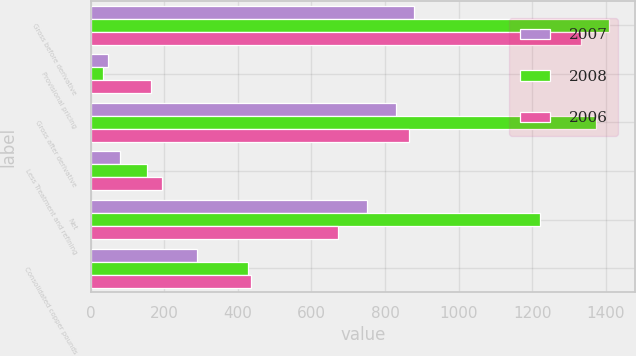Convert chart. <chart><loc_0><loc_0><loc_500><loc_500><stacked_bar_chart><ecel><fcel>Gross before derivative<fcel>Provisional pricing<fcel>Gross after derivative<fcel>Less Treatment and refining<fcel>Net<fcel>Consolidated copper pounds<nl><fcel>2007<fcel>878<fcel>47<fcel>831<fcel>79<fcel>752<fcel>290<nl><fcel>2008<fcel>1409<fcel>34<fcel>1374<fcel>153<fcel>1221<fcel>428<nl><fcel>2006<fcel>1333<fcel>165<fcel>865<fcel>194<fcel>671<fcel>435<nl></chart> 